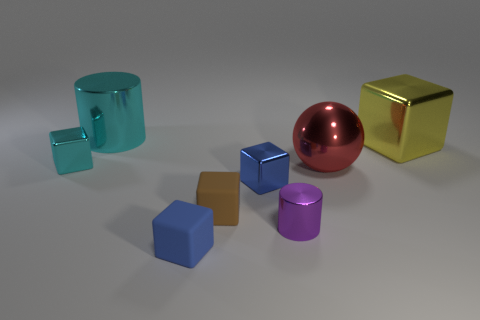What number of small objects are left of the small metallic cylinder and right of the small brown matte block? To the left of the small metallic cylinder and to the right of the small brown matte block, there is one small object - a blue cube. 